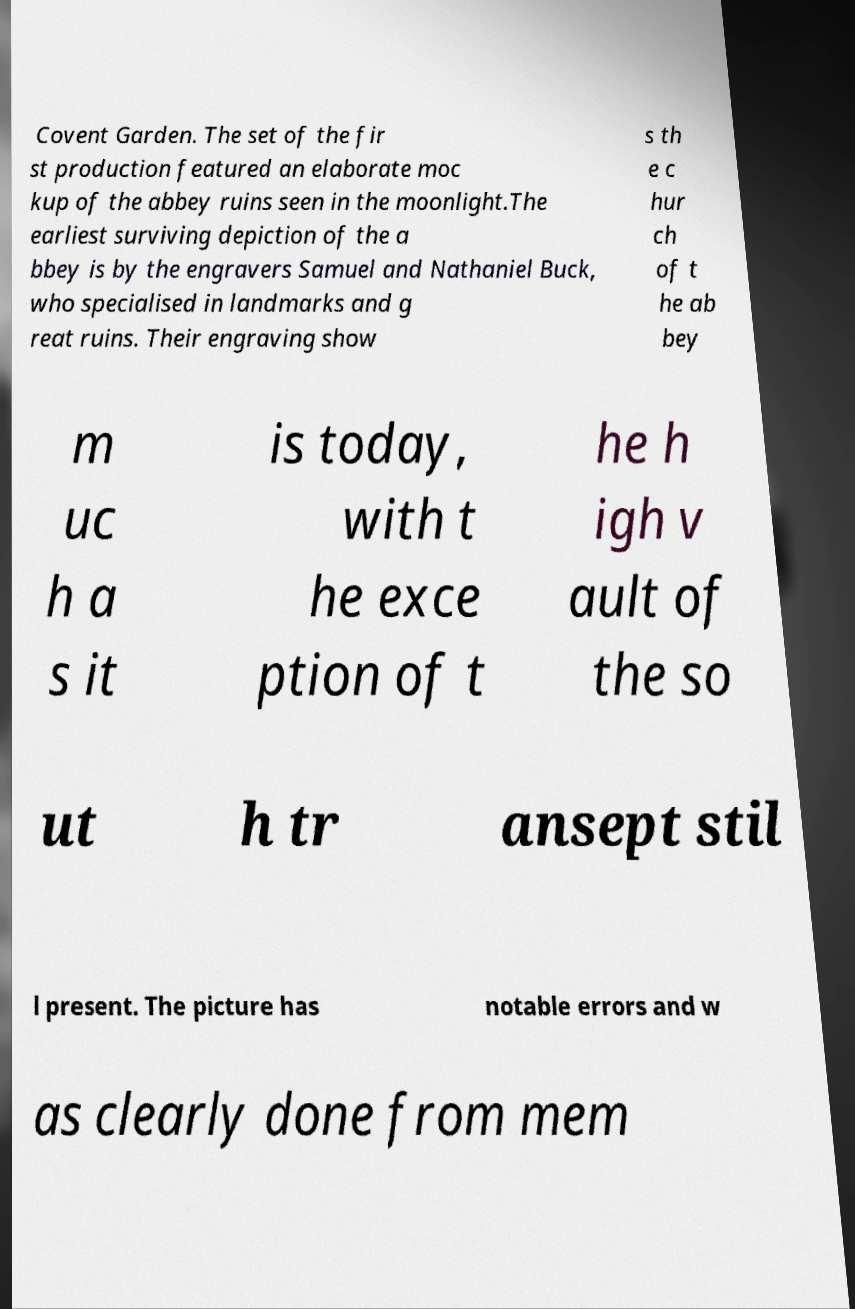For documentation purposes, I need the text within this image transcribed. Could you provide that? Covent Garden. The set of the fir st production featured an elaborate moc kup of the abbey ruins seen in the moonlight.The earliest surviving depiction of the a bbey is by the engravers Samuel and Nathaniel Buck, who specialised in landmarks and g reat ruins. Their engraving show s th e c hur ch of t he ab bey m uc h a s it is today, with t he exce ption of t he h igh v ault of the so ut h tr ansept stil l present. The picture has notable errors and w as clearly done from mem 